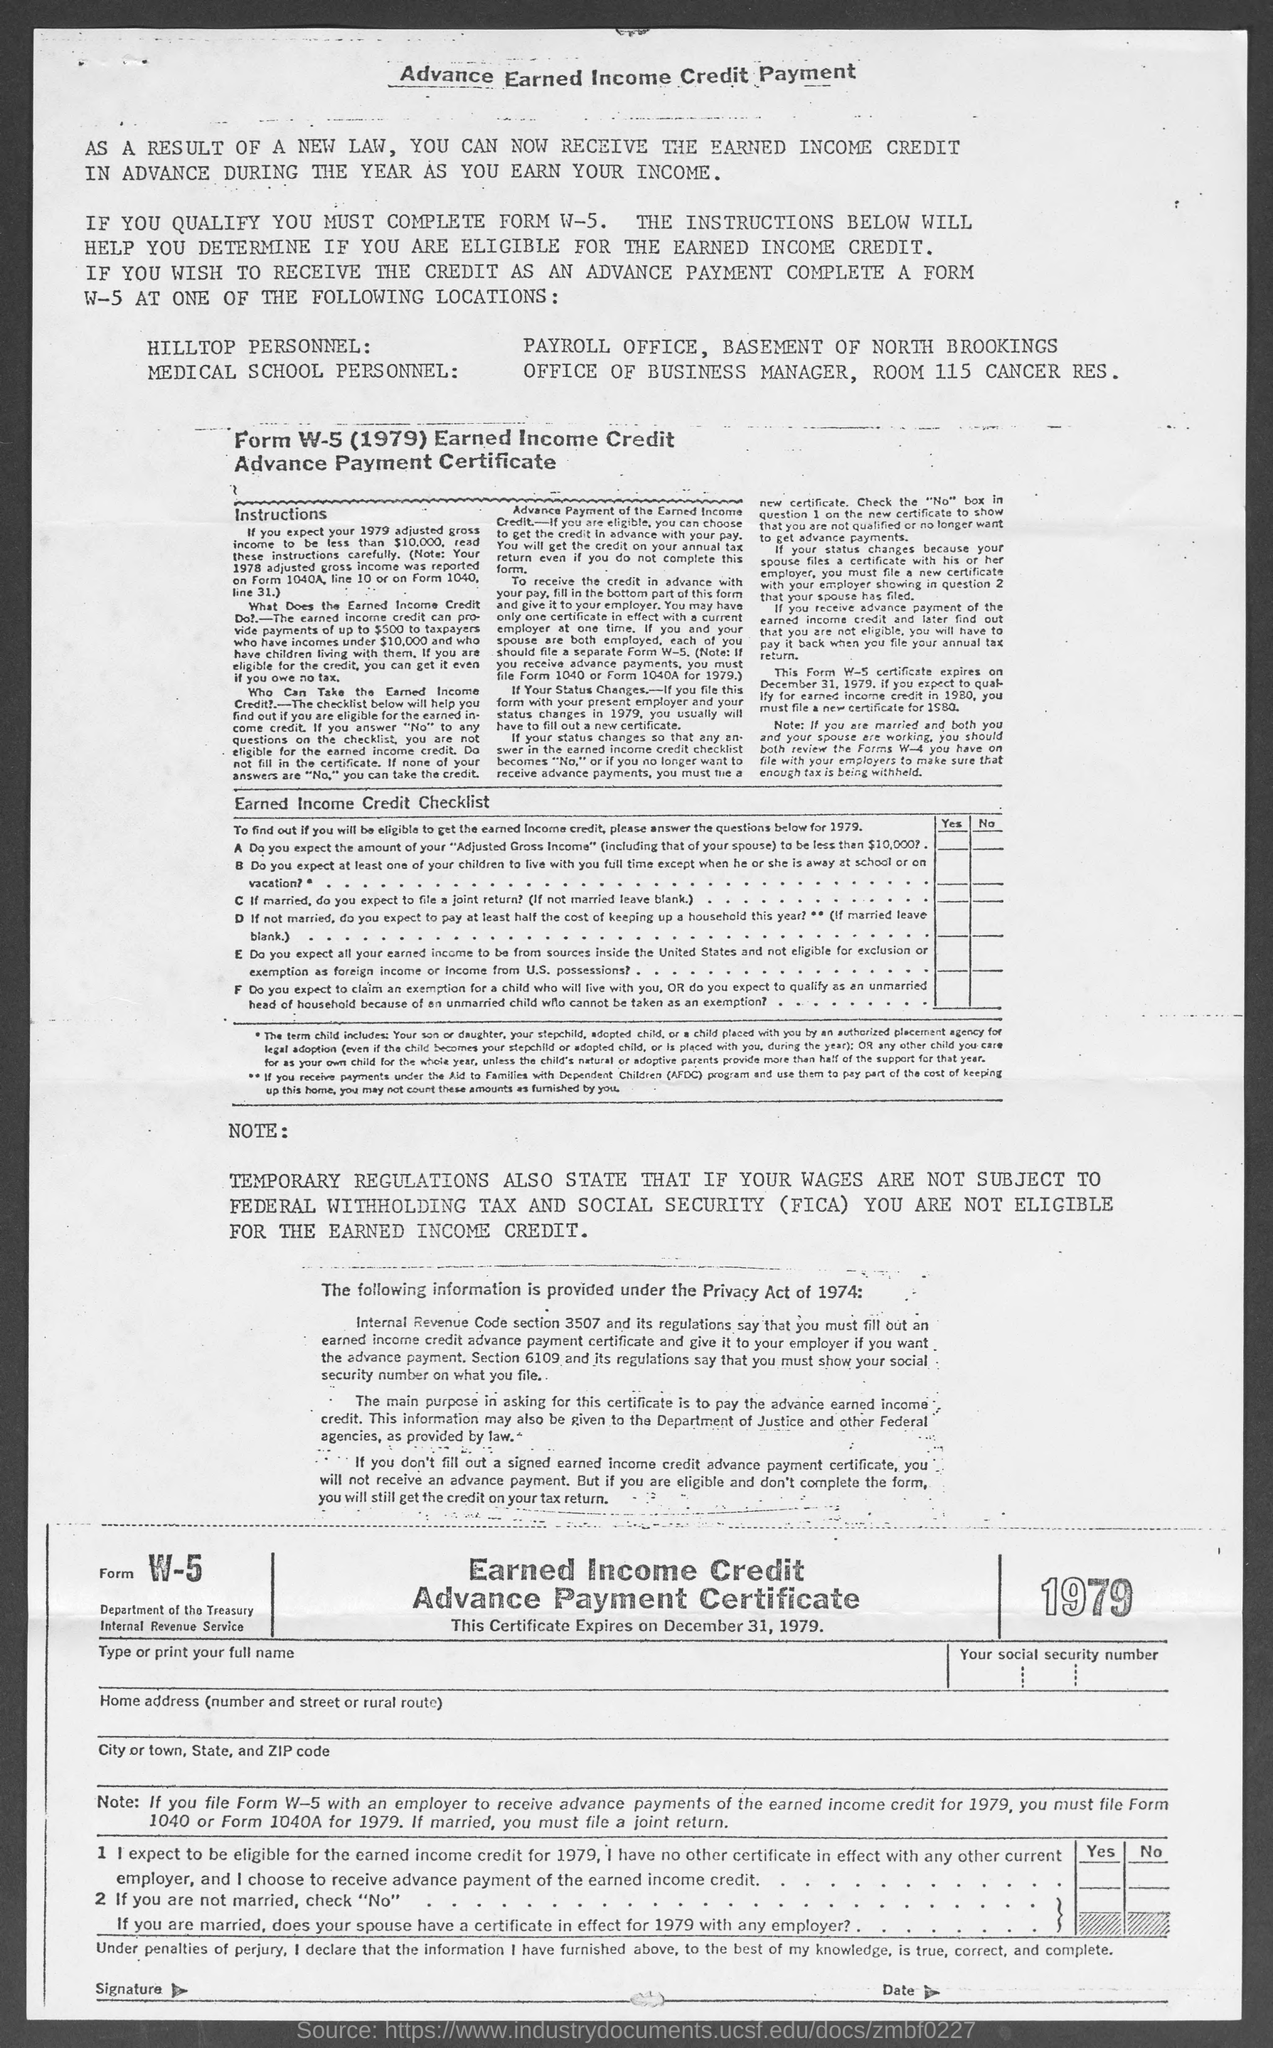When will this certificate expire ?
Offer a very short reply. DECEMBER 31,1979. 